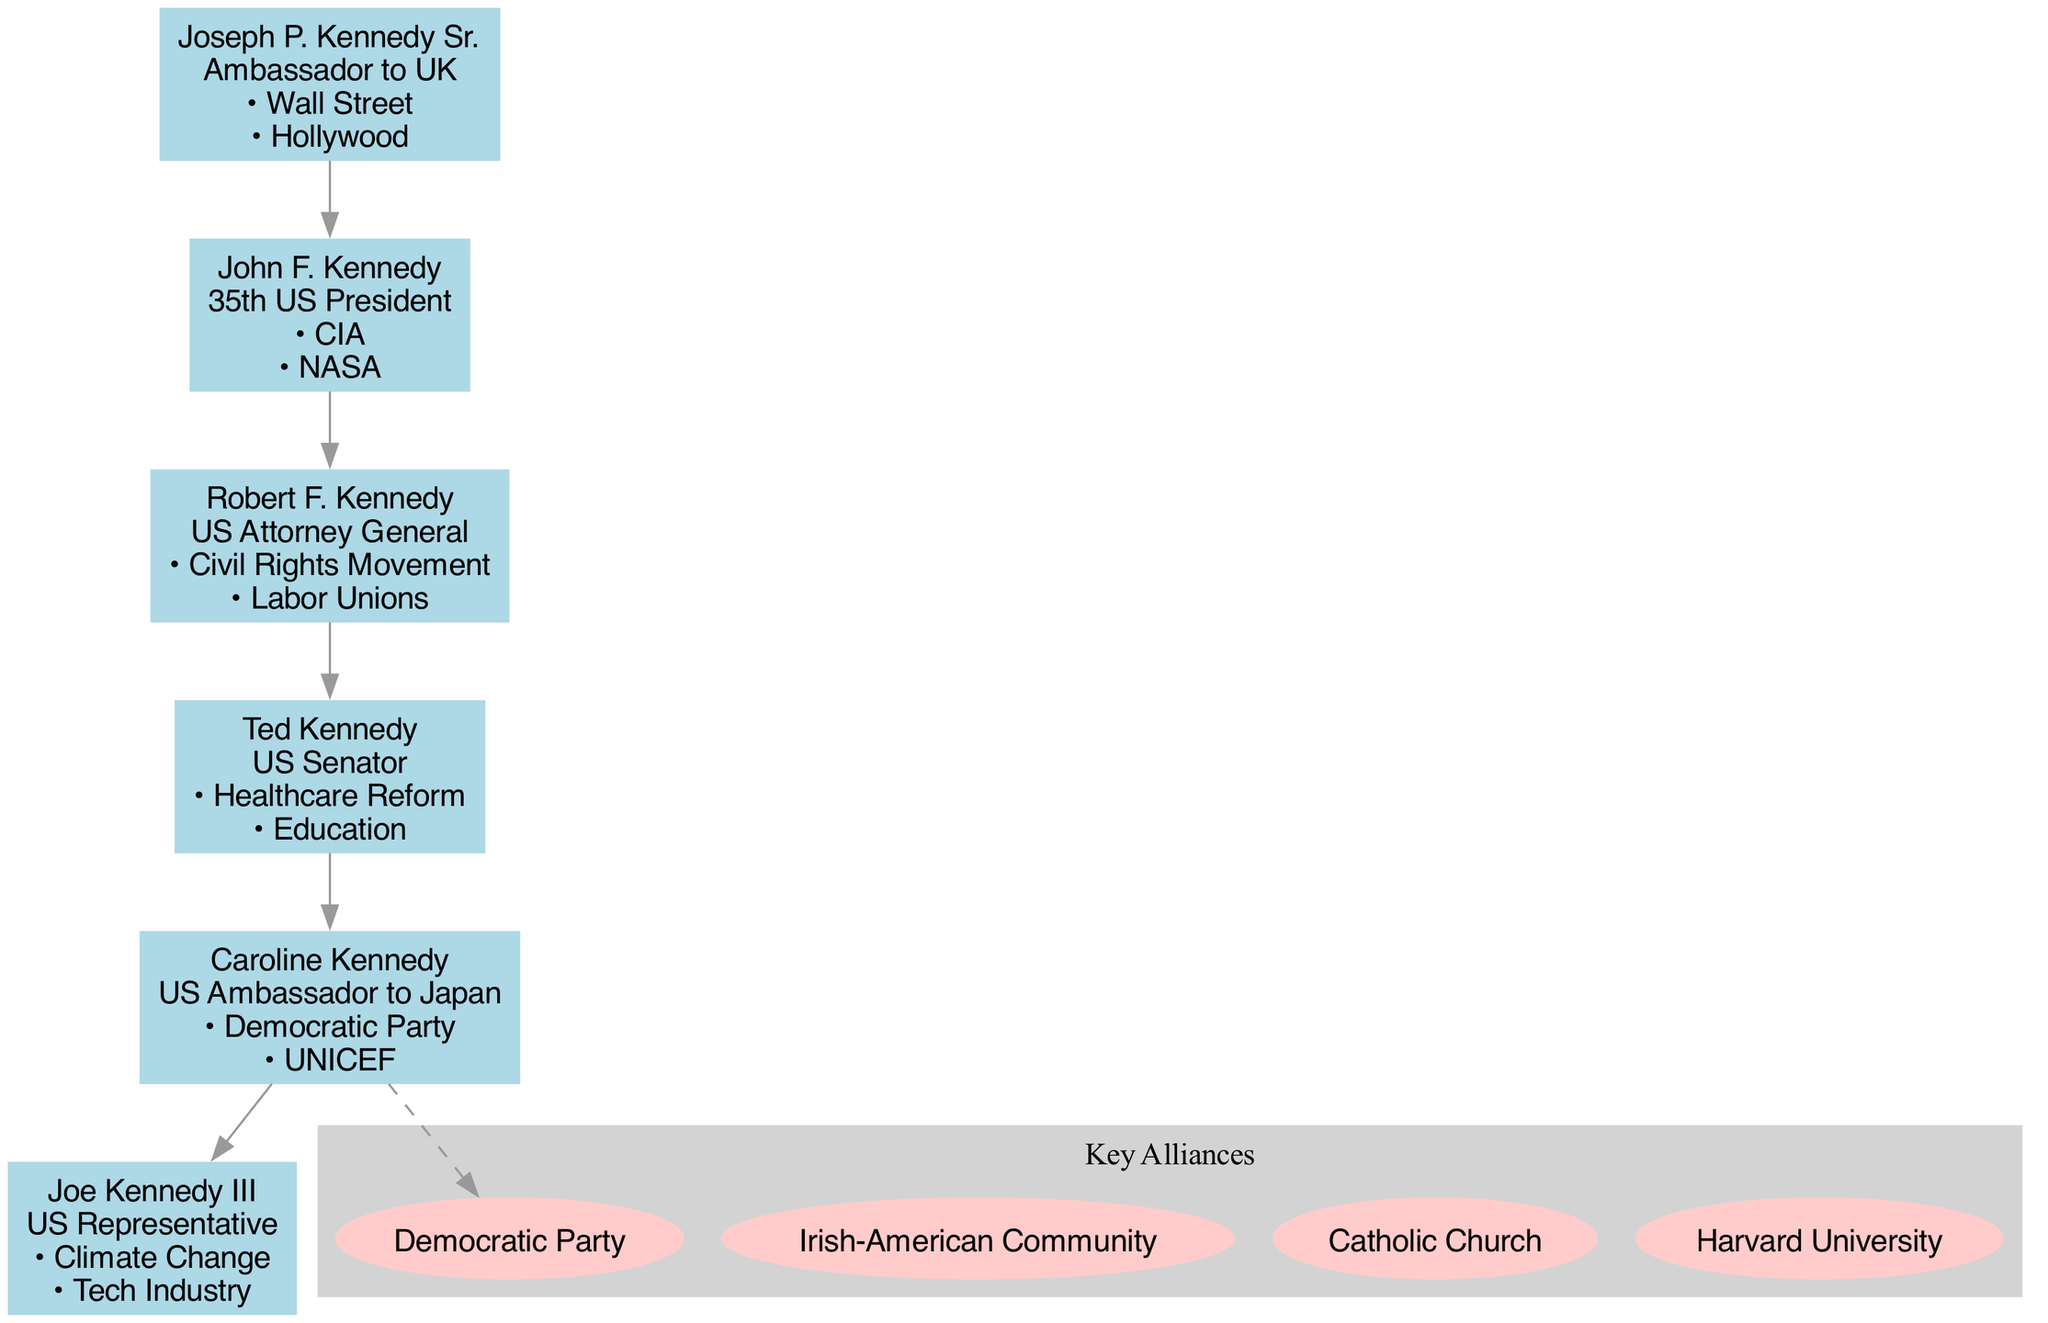What is the role of John F. Kennedy? The diagram shows that John F. Kennedy's role is listed as the 35th US President. This information can be found directly on his node in the family tree.
Answer: 35th US President How many generations are represented in the family tree? By counting the entries in the 'generations' data, we see there are 6 members represented, which indicates there are 6 generations shown in this particular family tree.
Answer: 6 Which family member is connected to the Civil Rights Movement? The diagram indicates that Robert F. Kennedy is the family member associated with the Civil Rights Movement, stated explicitly under his connections.
Answer: Robert F. Kennedy Which key alliance is shared by multiple generations in the family? The Democratic Party is noted as one of the key alliances, and its connection is found in multiple members' connections, including Caroline Kennedy and the general context of the family, suggesting its importance across generations.
Answer: Democratic Party How many key alliances are listed in the diagram? The key alliances listed are four in total: Democratic Party, Irish-American Community, Catholic Church, and Harvard University, which can be seen in the 'key_alliances' section of the data.
Answer: 4 Which family member has a connection to labor unions? According to the diagram, Robert F. Kennedy has a listed connection to labor unions, which is specifically included in his node.
Answer: Robert F. Kennedy What is the primary role of Caroline Kennedy? Caroline Kennedy is identified in the family tree as the US Ambassador to Japan, as indicated in her node.
Answer: US Ambassador to Japan Which member is linked to Climate Change initiatives? The diagram specifies that Joe Kennedy III is the family member connected to Climate Change, noted in his role’s connections.
Answer: Joe Kennedy III Who was the Ambassador to the UK? The family tree labels Joseph P. Kennedy Sr. as the Ambassador to the UK, making this information clear and accessible from his node.
Answer: Joseph P. Kennedy Sr 